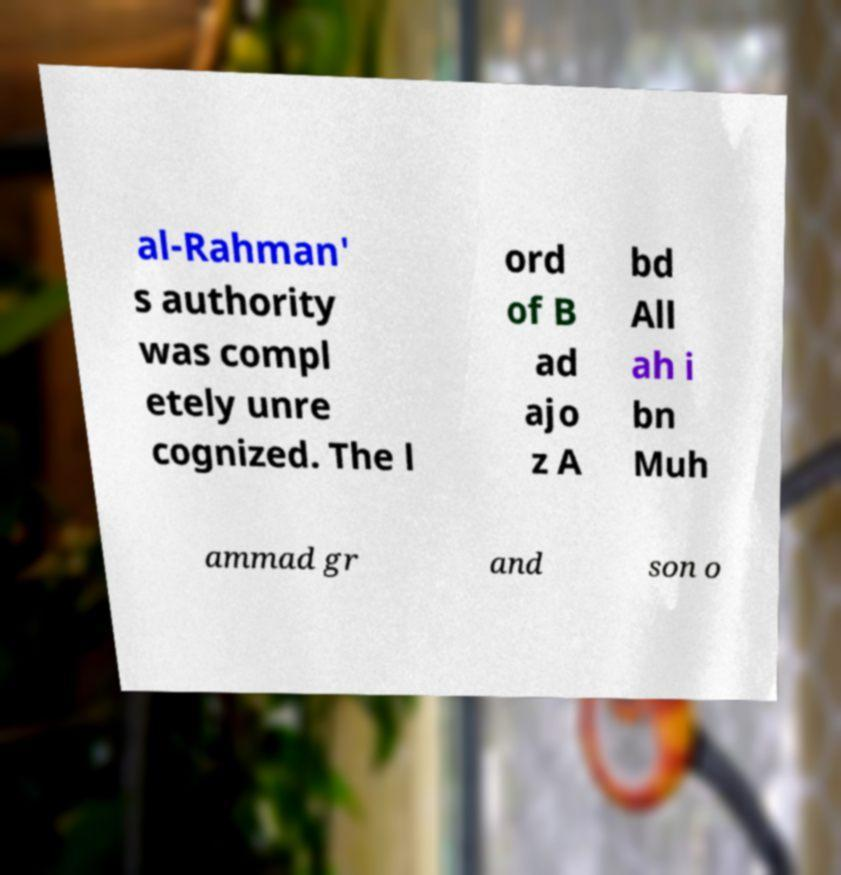Could you extract and type out the text from this image? al-Rahman' s authority was compl etely unre cognized. The l ord of B ad ajo z A bd All ah i bn Muh ammad gr and son o 